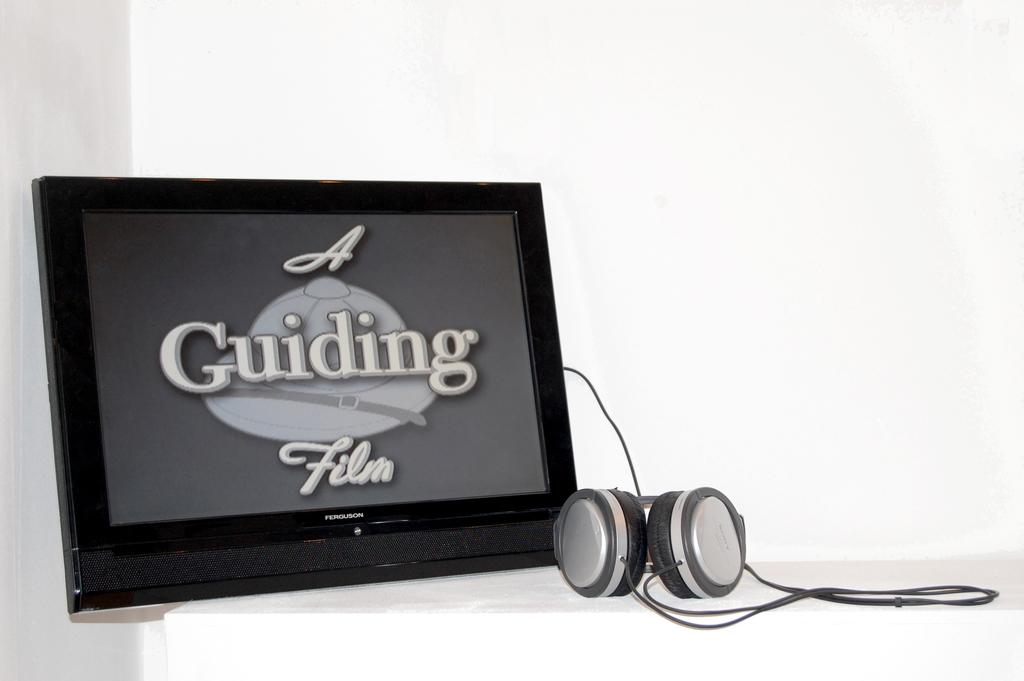What electronic device is present in the image? There is a television in the image. What accessory is visible in the image? There is a headset in the image. What color is the background of the image? The background of the image is white. What is being displayed on the television screen? Text is displayed on the screen of the television. Can you tell me how many partners are involved in the discussion taking place in the image? There is no discussion or partners present in the image; it only features a television and a headset. What type of gate can be seen in the image? There is no gate present in the image. 